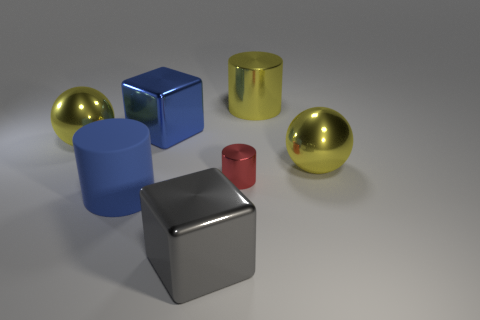Add 2 big red matte cubes. How many objects exist? 9 Subtract all balls. How many objects are left? 5 Add 4 big gray shiny objects. How many big gray shiny objects exist? 5 Subtract 0 red cubes. How many objects are left? 7 Subtract all yellow spheres. Subtract all blue rubber objects. How many objects are left? 4 Add 2 small red metallic things. How many small red metallic things are left? 3 